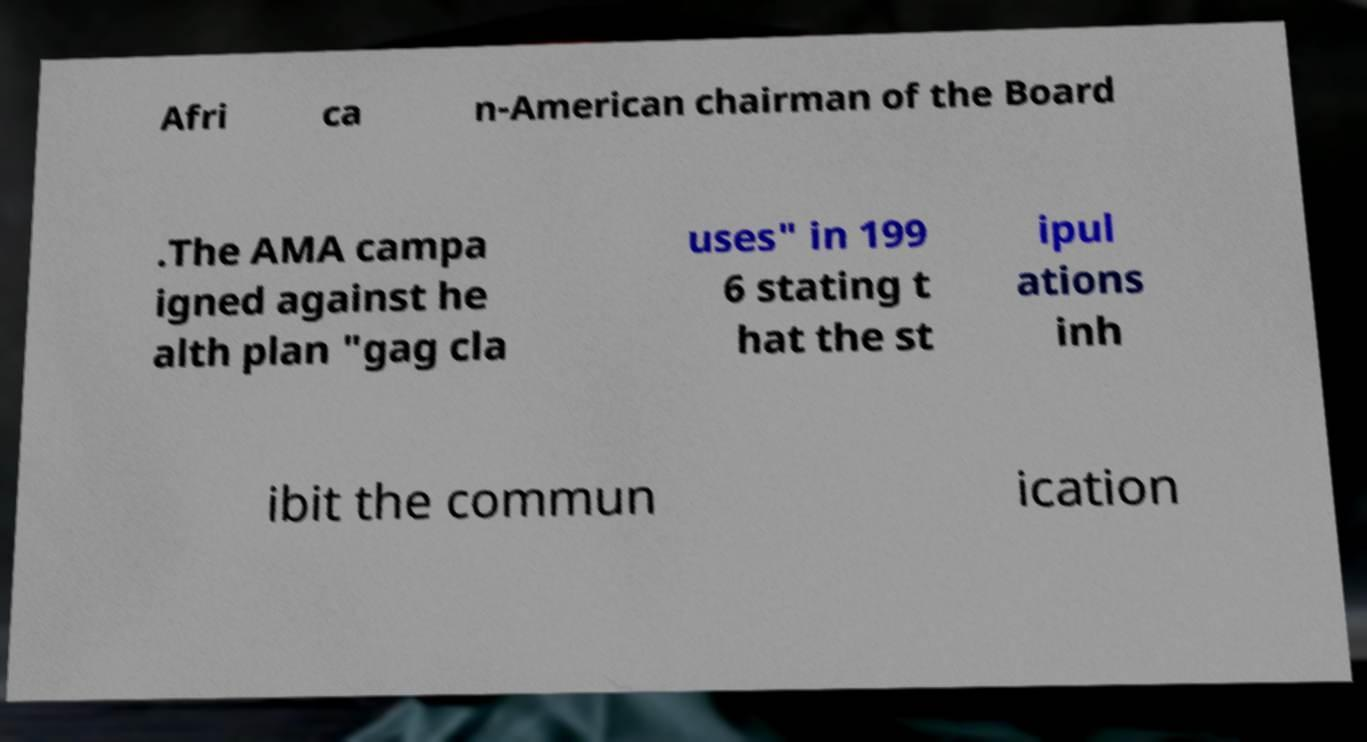Please identify and transcribe the text found in this image. Afri ca n-American chairman of the Board .The AMA campa igned against he alth plan "gag cla uses" in 199 6 stating t hat the st ipul ations inh ibit the commun ication 